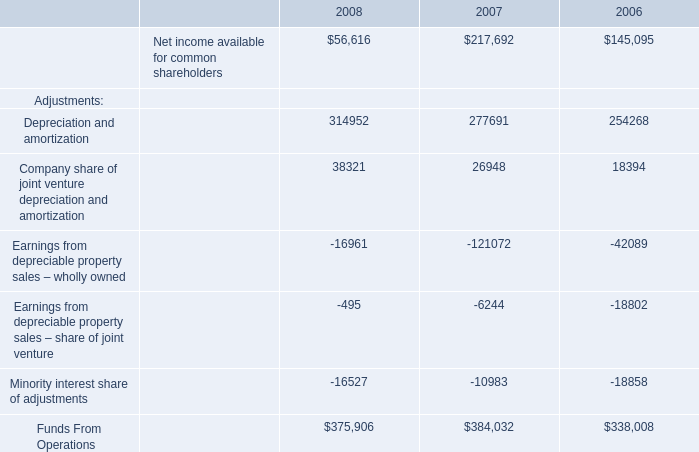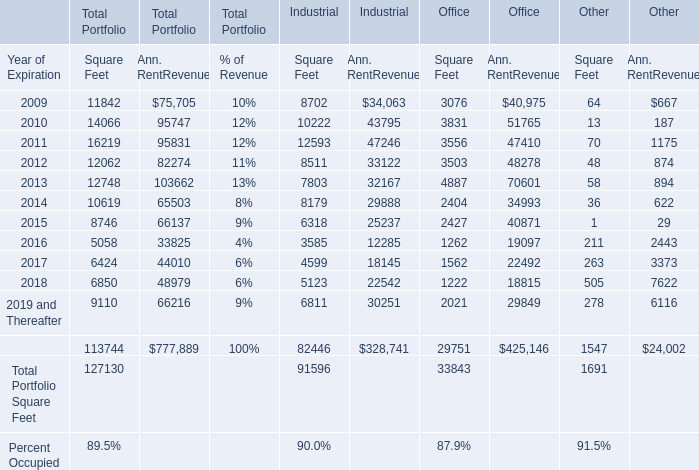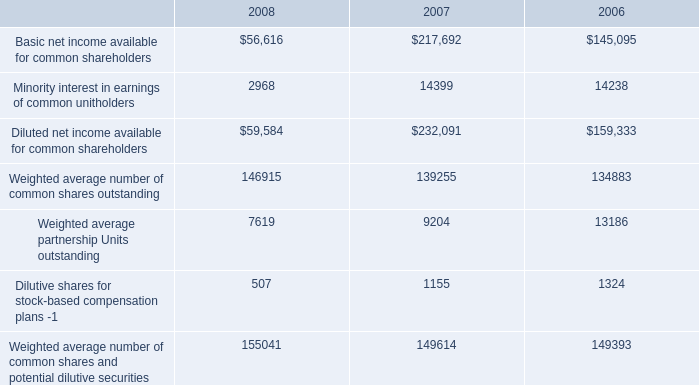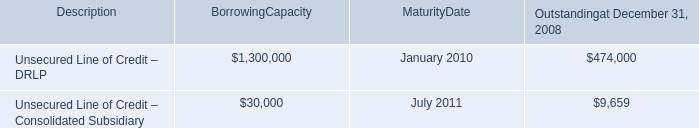what is the net income per common share in 2008? 
Computations: (56616 / 146915)
Answer: 0.38537. 